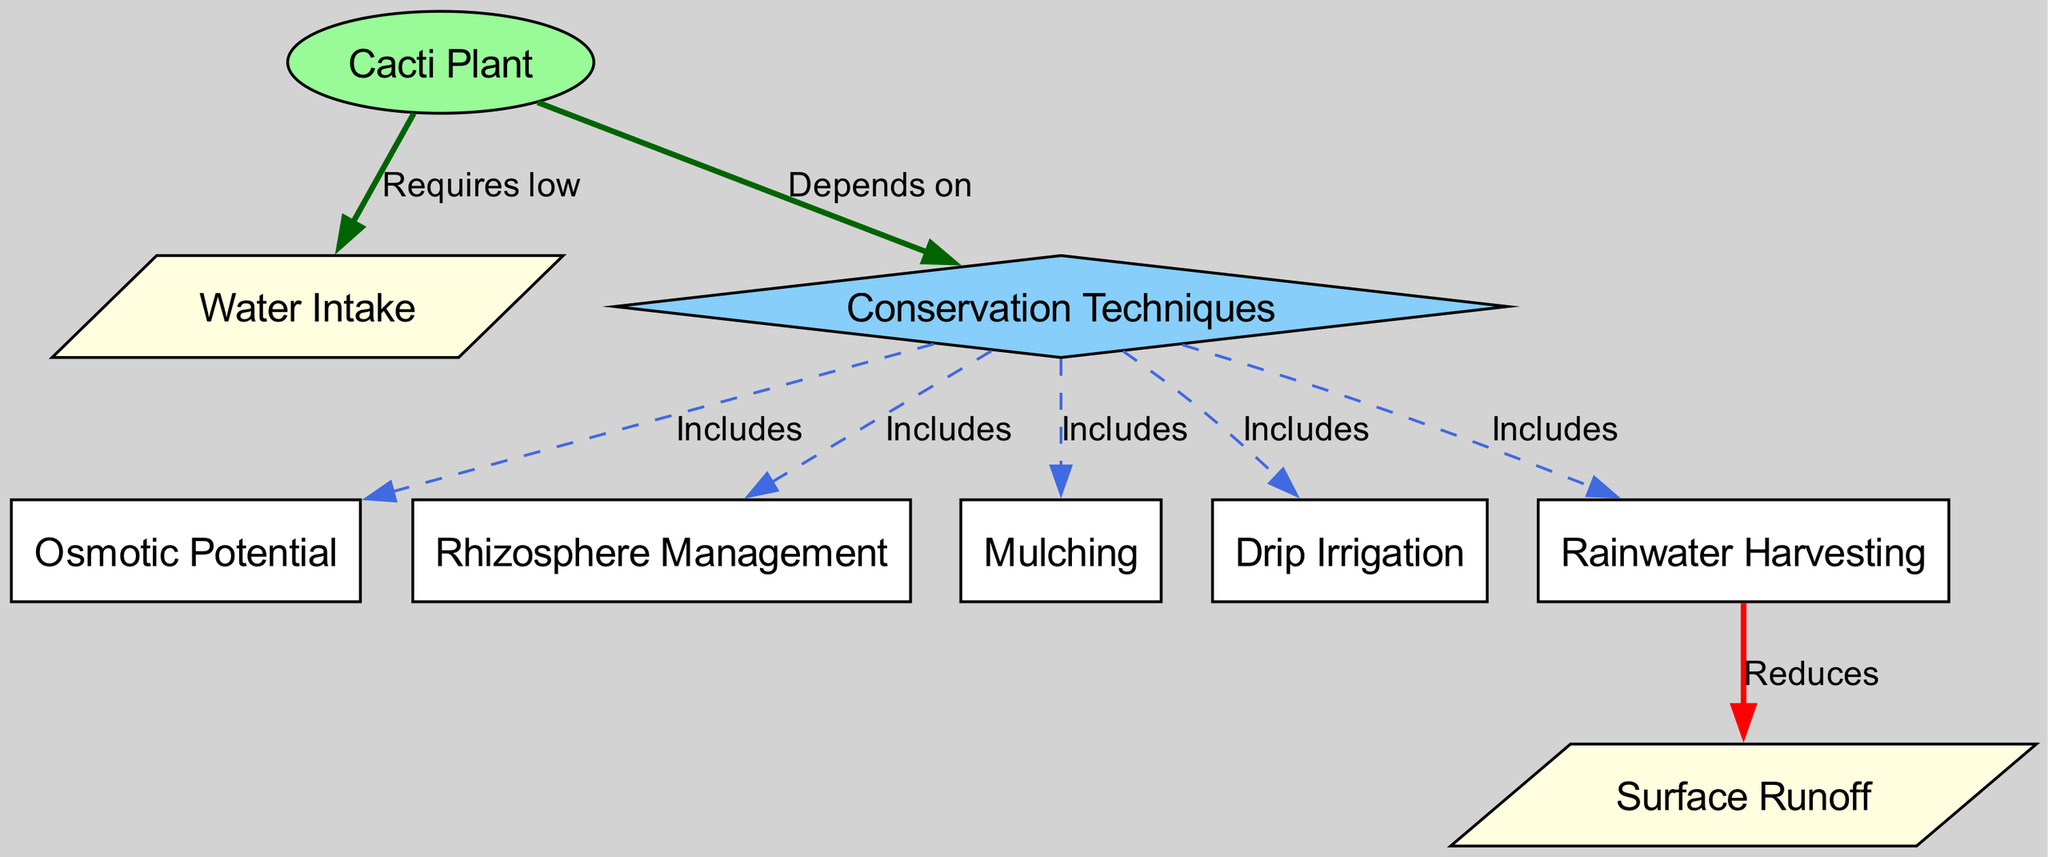What is the relationship between the Cacti Plant and Water Intake? The diagram indicates that the Cacti Plant requires low Water Intake, which is a direct relationship depicted by the edge labeled "Requires low."
Answer: Requires low How many conservation techniques are listed in the diagram? There are five conservation techniques listed, which include osmotic potential, rhizosphere management, mulching, drip irrigation, and rainwater harvesting.
Answer: Five What does Rainwater Harvesting reduce? The diagram states that Rainwater Harvesting reduces Surface Runoff, indicated by the edge labeled "Reduces."
Answer: Surface Runoff What type of node is the Conservation Techniques labeled as? The node labeled Conservation Techniques is shaped as a diamond, which denotes its classification in the diagram.
Answer: Diamond Which technique enhances Osmotic Potential? The Conservation Techniques include Osmotic Potential, which is facilitated by various methods represented in the diagram.
Answer: Osmotic Potential What color is the Cacti Plant node? The Cacti Plant node is colored pale green, as specified in the styling attributes for that particular node.
Answer: Pale green How does Mulching relate to Conservation Techniques? Mulching is included within Conservation Techniques, as shown by the edge labeled "Includes" connecting them in the diagram.
Answer: Includes What effect does the Cacti Plant have on Water Intake? The Cacti Plant requires a low Water Intake, which determines its water consumption strategy in arid conditions.
Answer: Low Which technique manages the rhizosphere? The diagram lists Rhizosphere Management as a technique included in Conservation Techniques, indicating its role in water conservation.
Answer: Rhizosphere Management 